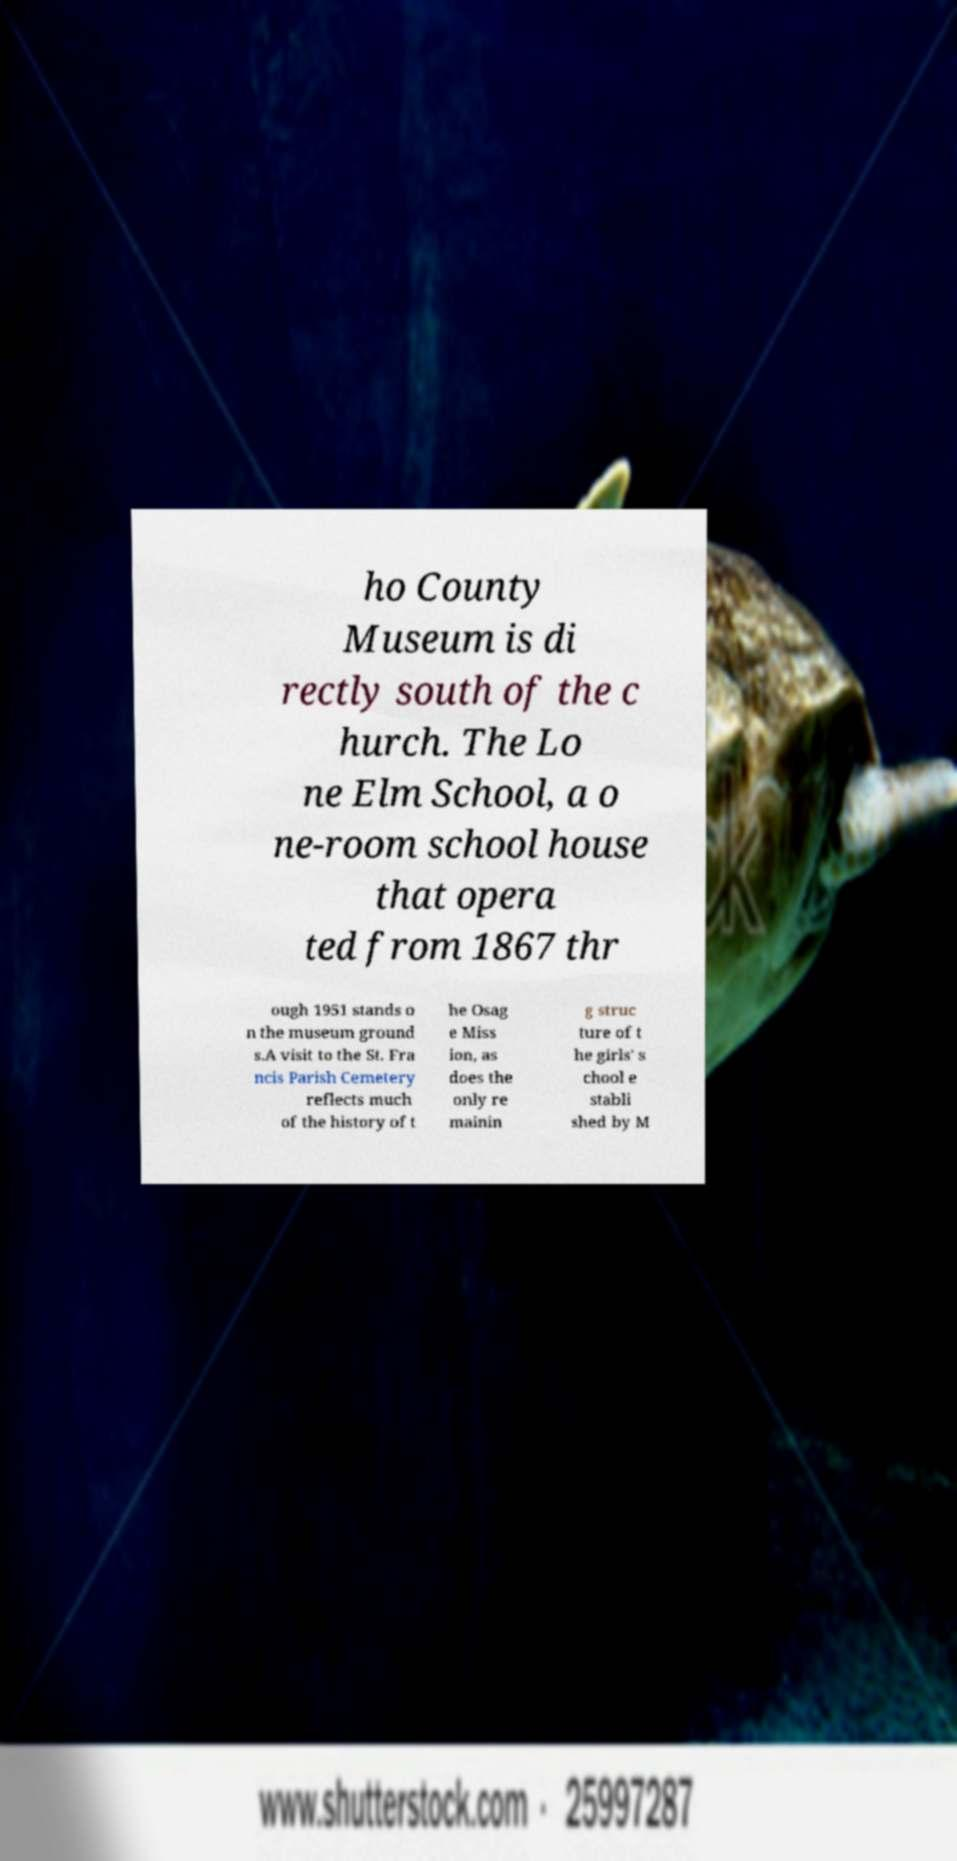Please read and relay the text visible in this image. What does it say? ho County Museum is di rectly south of the c hurch. The Lo ne Elm School, a o ne-room school house that opera ted from 1867 thr ough 1951 stands o n the museum ground s.A visit to the St. Fra ncis Parish Cemetery reflects much of the history of t he Osag e Miss ion, as does the only re mainin g struc ture of t he girls' s chool e stabli shed by M 